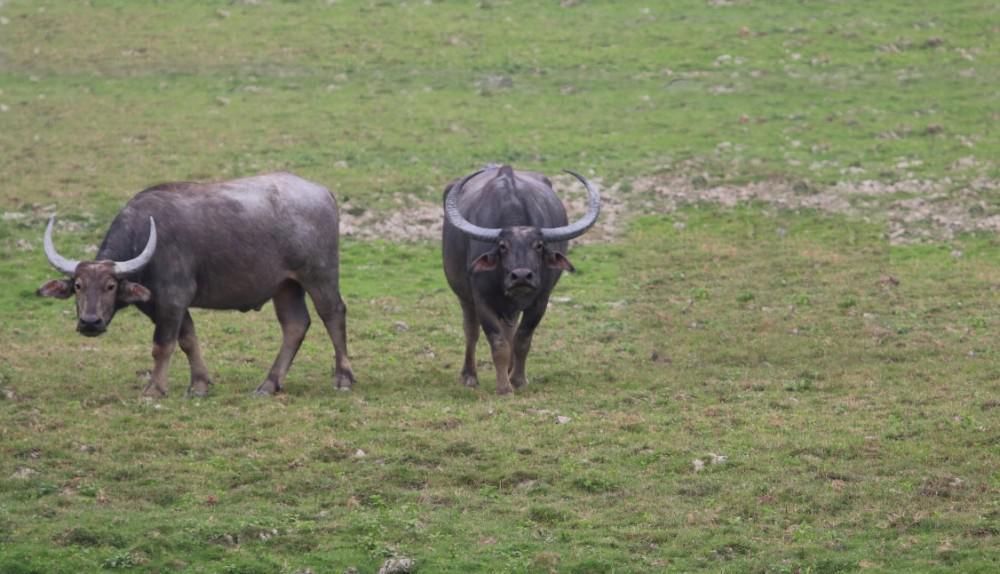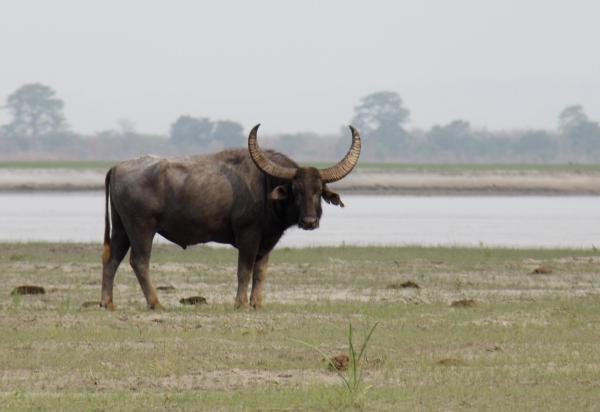The first image is the image on the left, the second image is the image on the right. Analyze the images presented: Is the assertion "At least one of the images includes a body of water that there are no water buffalos in." valid? Answer yes or no. Yes. The first image is the image on the left, the second image is the image on the right. Assess this claim about the two images: "At least one image in the pair contains only one ox.". Correct or not? Answer yes or no. Yes. 